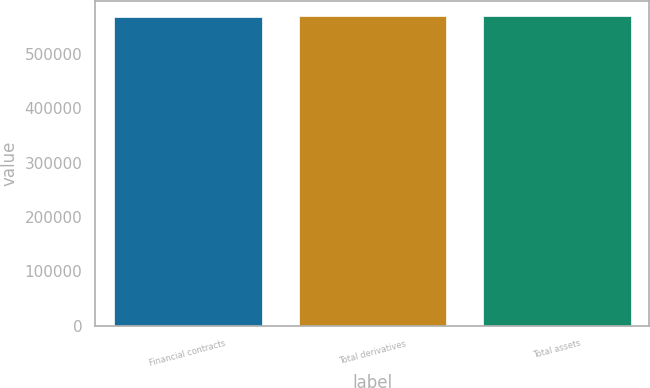Convert chart. <chart><loc_0><loc_0><loc_500><loc_500><bar_chart><fcel>Financial contracts<fcel>Total derivatives<fcel>Total assets<nl><fcel>568888<fcel>569243<fcel>569278<nl></chart> 